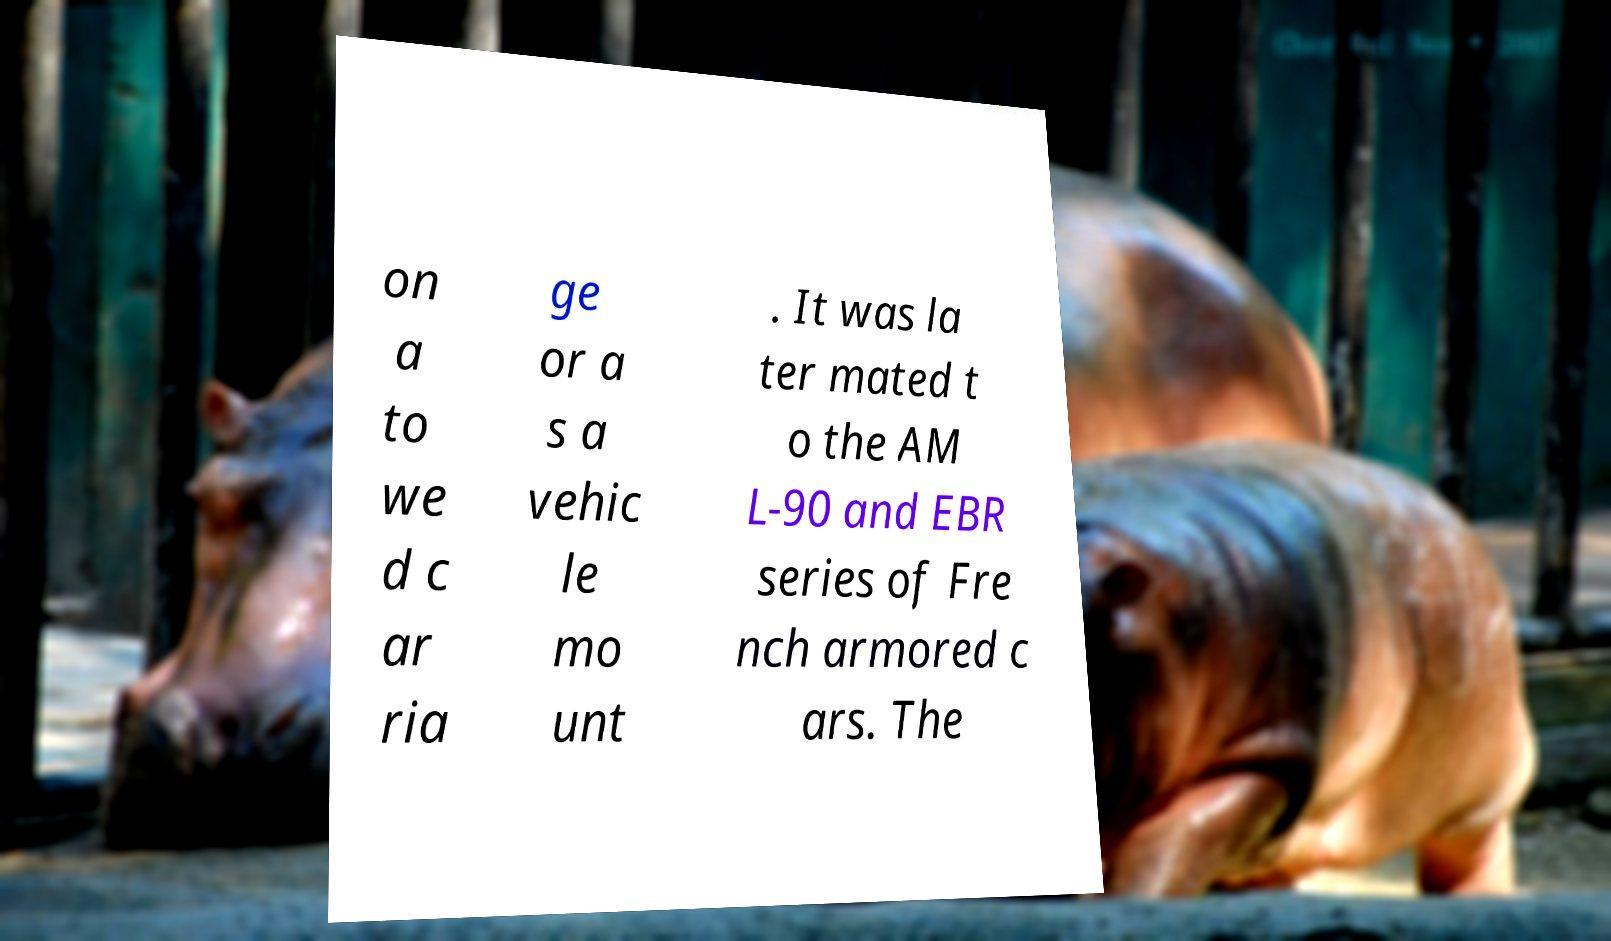Can you accurately transcribe the text from the provided image for me? on a to we d c ar ria ge or a s a vehic le mo unt . It was la ter mated t o the AM L-90 and EBR series of Fre nch armored c ars. The 